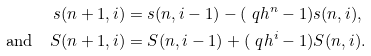<formula> <loc_0><loc_0><loc_500><loc_500>s ( n + 1 , i ) & = s ( n , i - 1 ) - ( \ q h ^ { n } - 1 ) s ( n , i ) , \\ \text {and} \quad S ( n + 1 , i ) & = S ( n , i - 1 ) + ( \ q h ^ { i } - 1 ) S ( n , i ) .</formula> 